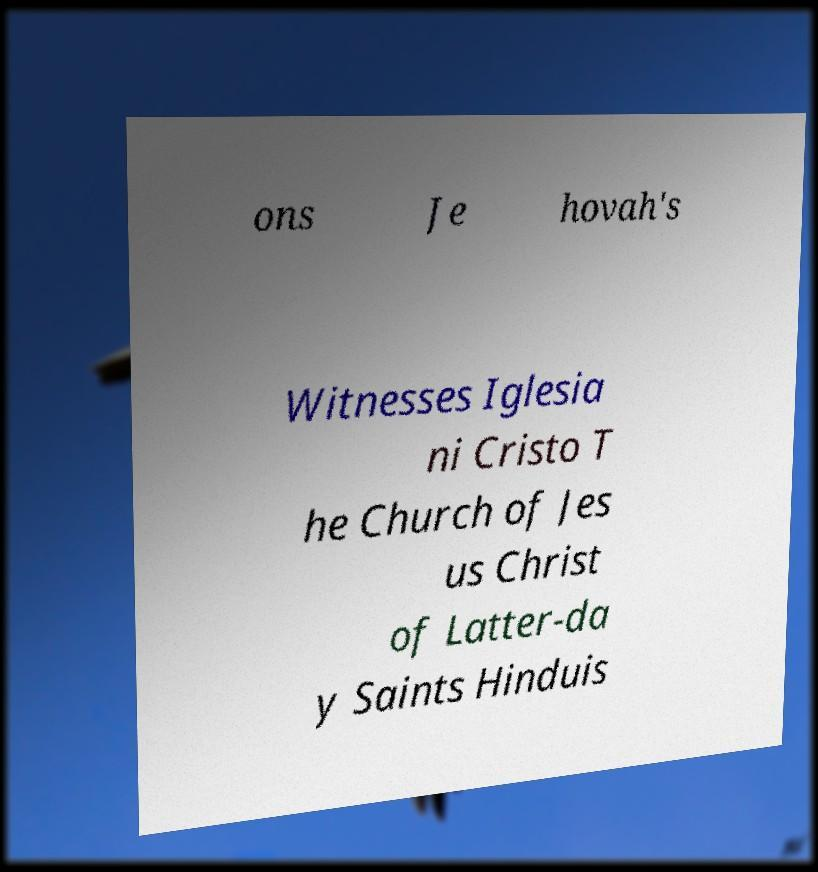Can you read and provide the text displayed in the image?This photo seems to have some interesting text. Can you extract and type it out for me? ons Je hovah's Witnesses Iglesia ni Cristo T he Church of Jes us Christ of Latter-da y Saints Hinduis 